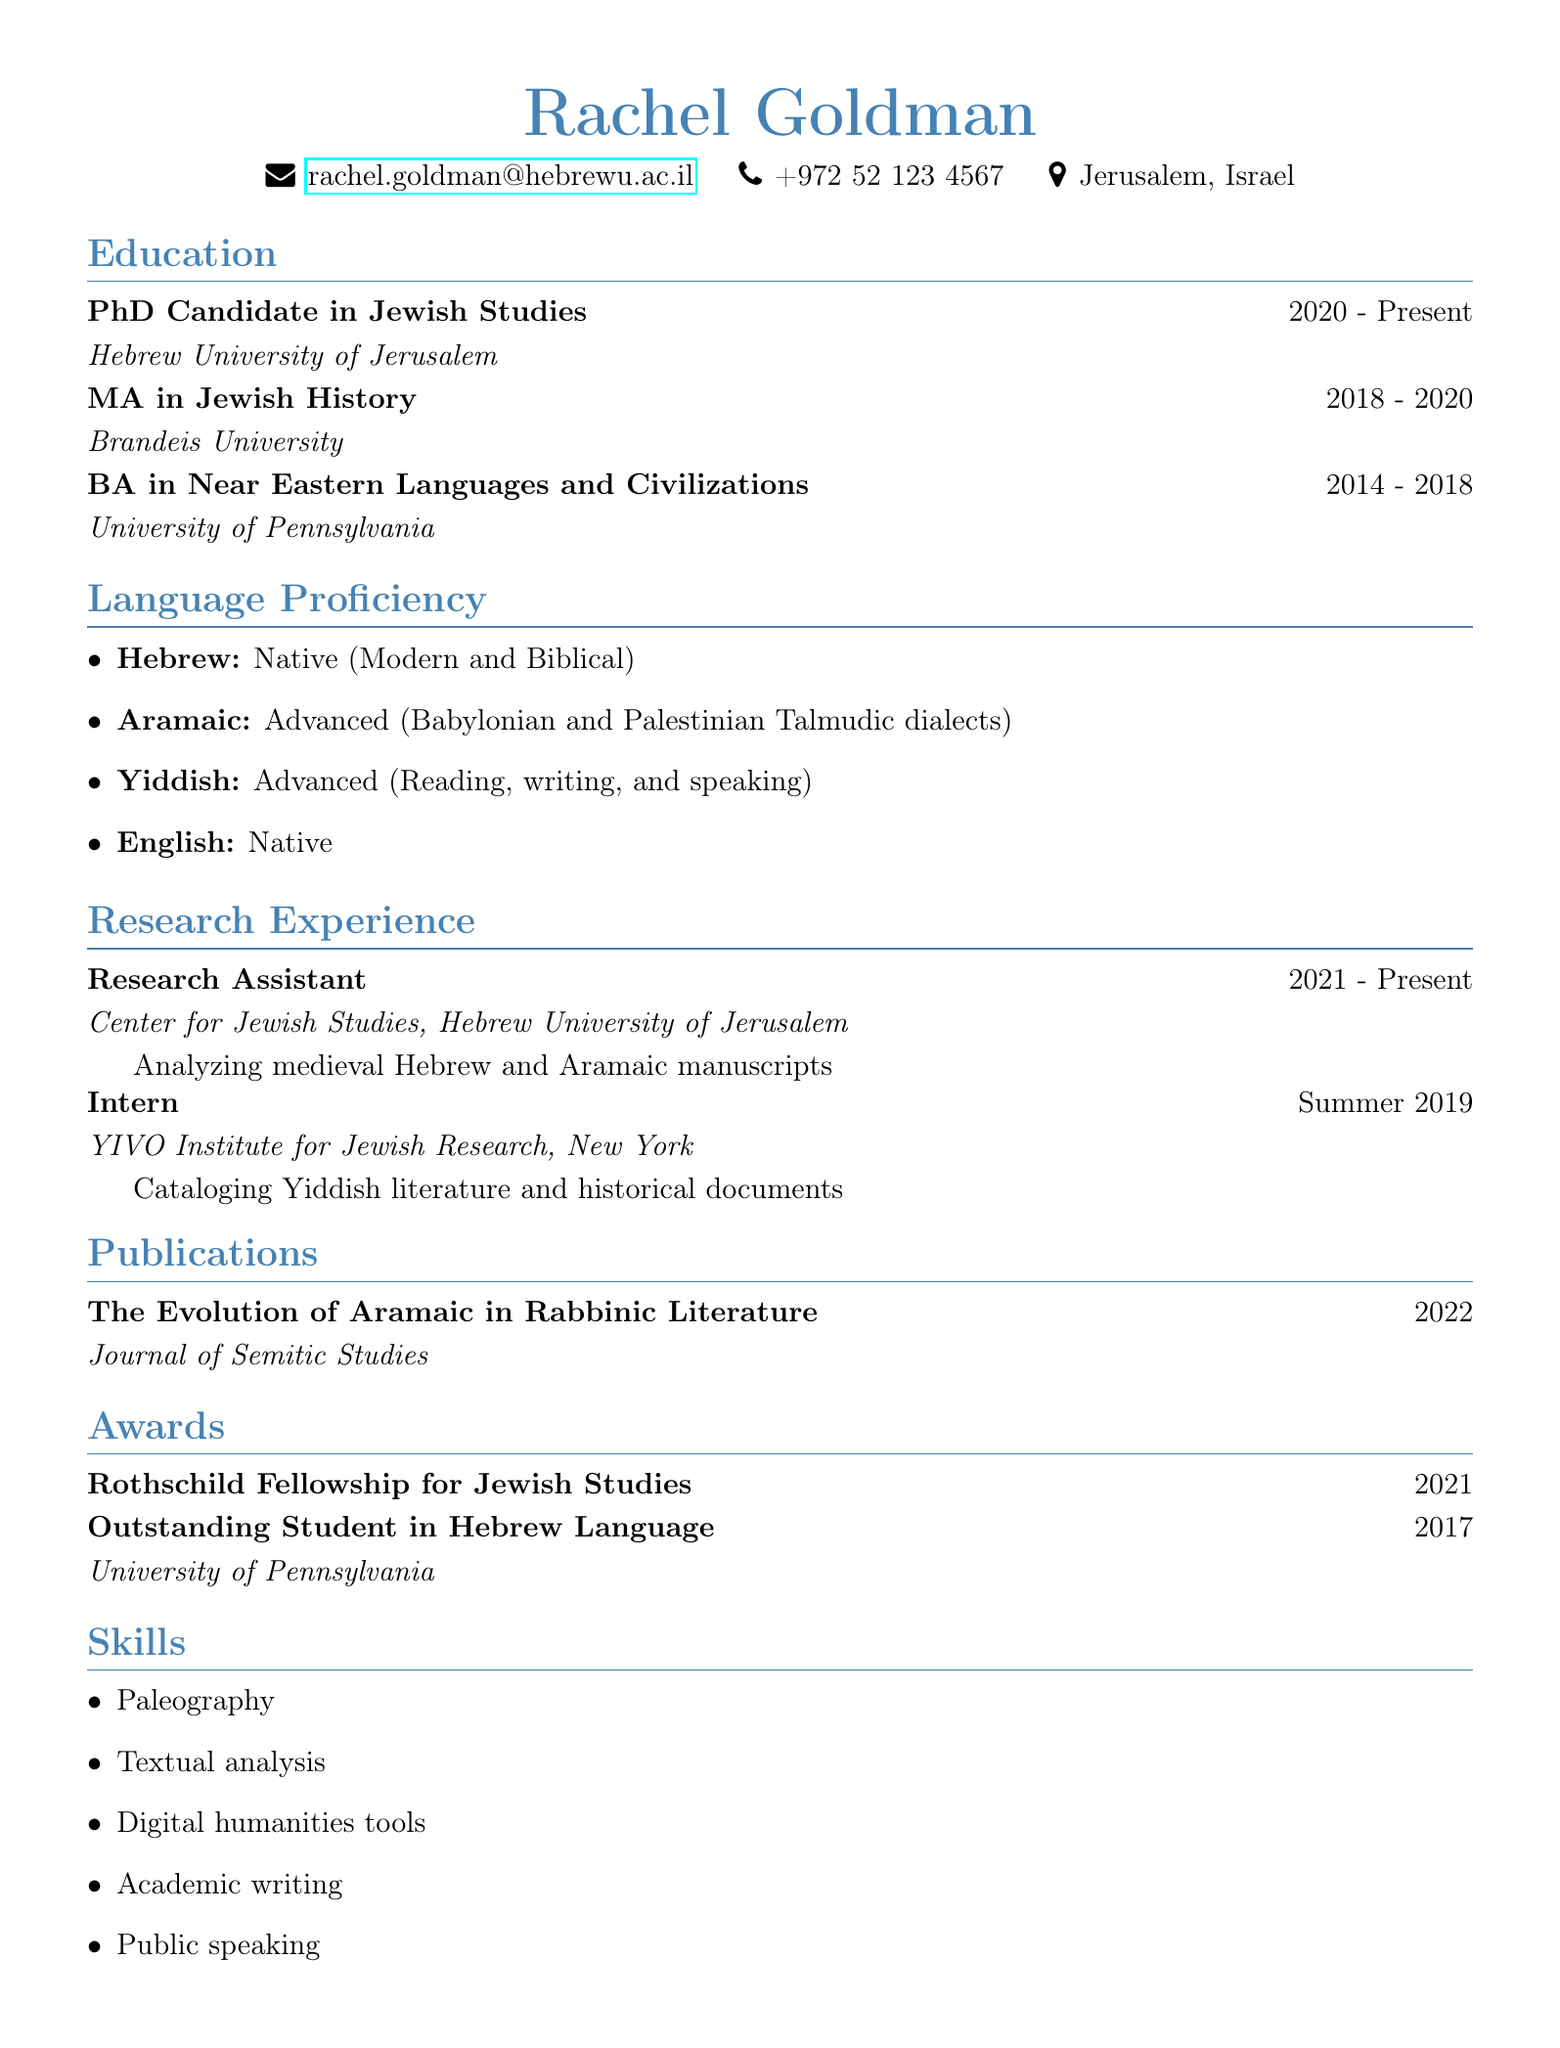What is Rachel Goldman's email? Rachel Goldman's email is found in the personal information section of the document.
Answer: rachel.goldman@hebrewu.ac.il What degree is Rachel currently pursuing? The current degree is listed under the education section.
Answer: PhD Candidate in Jewish Studies In which year did Rachel complete her MA? The completion year of the MA degree is noted in the education section.
Answer: 2020 What is Rachel's proficiency level in Yiddish? The language proficiency details provide information about the level of proficiency in Yiddish.
Answer: Advanced What award did Rachel receive in 2021? The awards section lists the awards Rachel received along with their respective years.
Answer: Rothschild Fellowship for Jewish Studies Which university did Rachel attend for her undergraduate degree? The institution for the undergraduate degree is mentioned in the education section of the document.
Answer: University of Pennsylvania What type of analysis is Rachel involved in as a Research Assistant? The description of Rachel's research assistant role indicates the specific analytical work she is doing.
Answer: Analyzing medieval Hebrew and Aramaic manuscripts How many languages is Rachel proficient in? The language proficiency section details the different languages Rachel speaks, indicating the count.
Answer: Four 